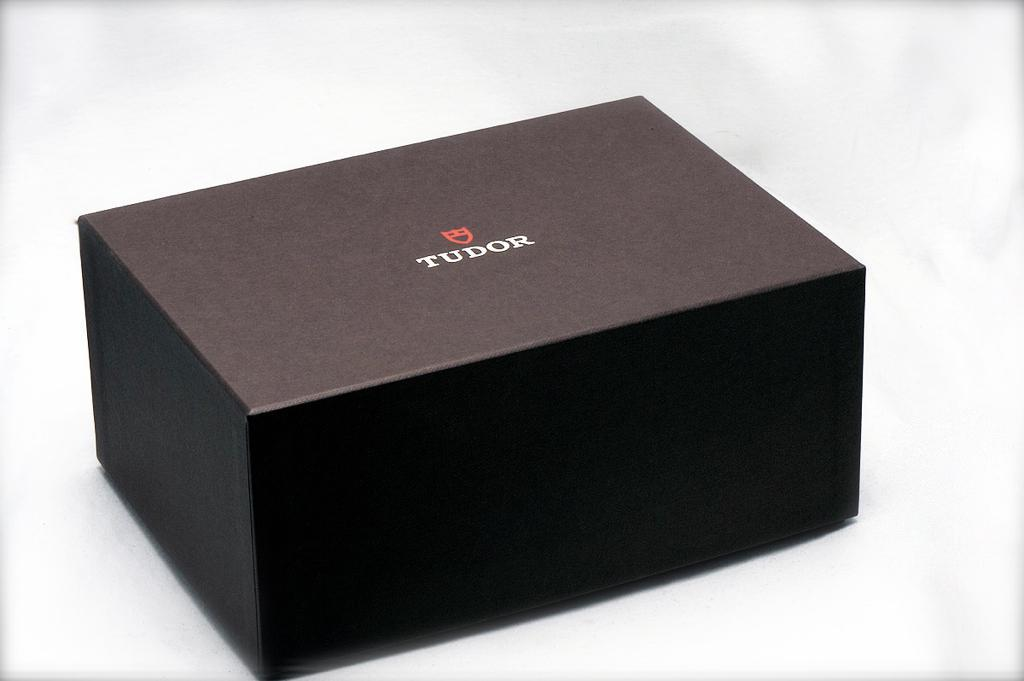<image>
Provide a brief description of the given image. Dark Gray Box that has the text Tudor on the top center. 